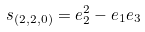<formula> <loc_0><loc_0><loc_500><loc_500>s _ { ( 2 , 2 , 0 ) } = e _ { 2 } ^ { 2 } - e _ { 1 } e _ { 3 }</formula> 